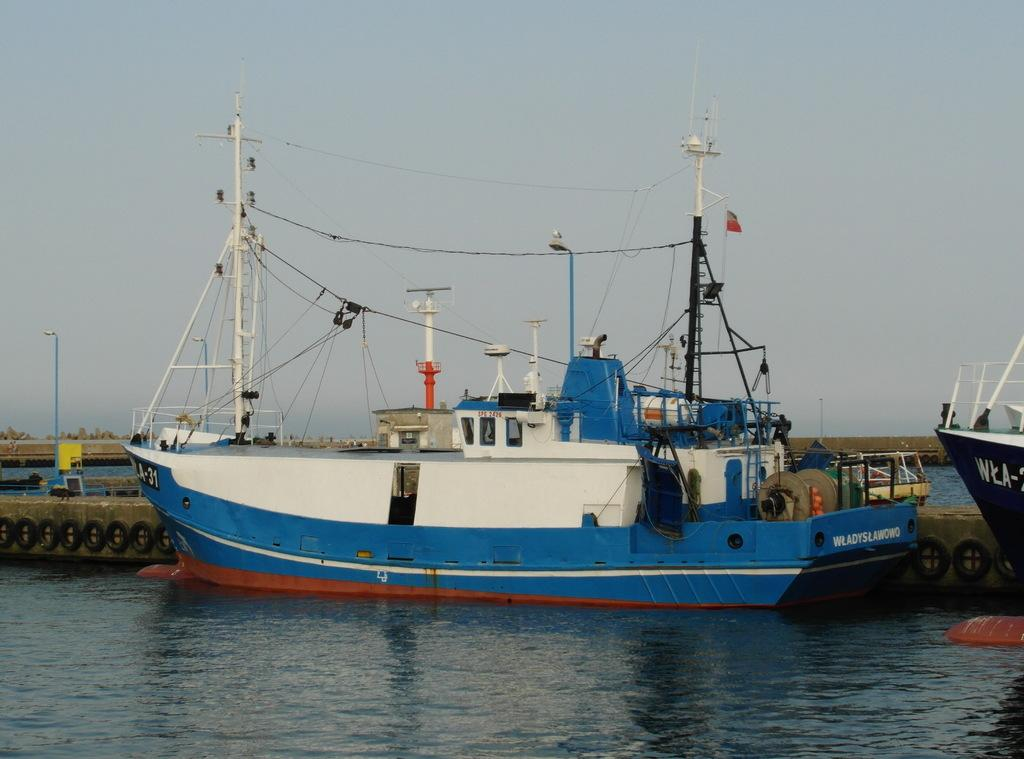What is in the water in the image? There are ships in the water in the image. What can be seen on the left side of the image? There is a light pole on the left side of the image. What is visible in the sky in the image? There are clouds in the sky in the image. What type of honey is being produced by the ships in the image? There is no honey production in the image; it features ships in the water and a light pole on the left side. 